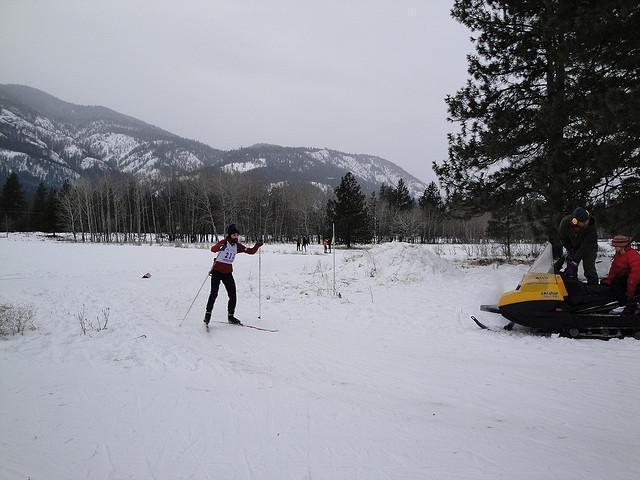What is the name of the yellow vehicle the man in red is on?
Choose the right answer from the provided options to respond to the question.
Options: Snow scooter, snowmobile, snow quad, ski truck. Snowmobile. 